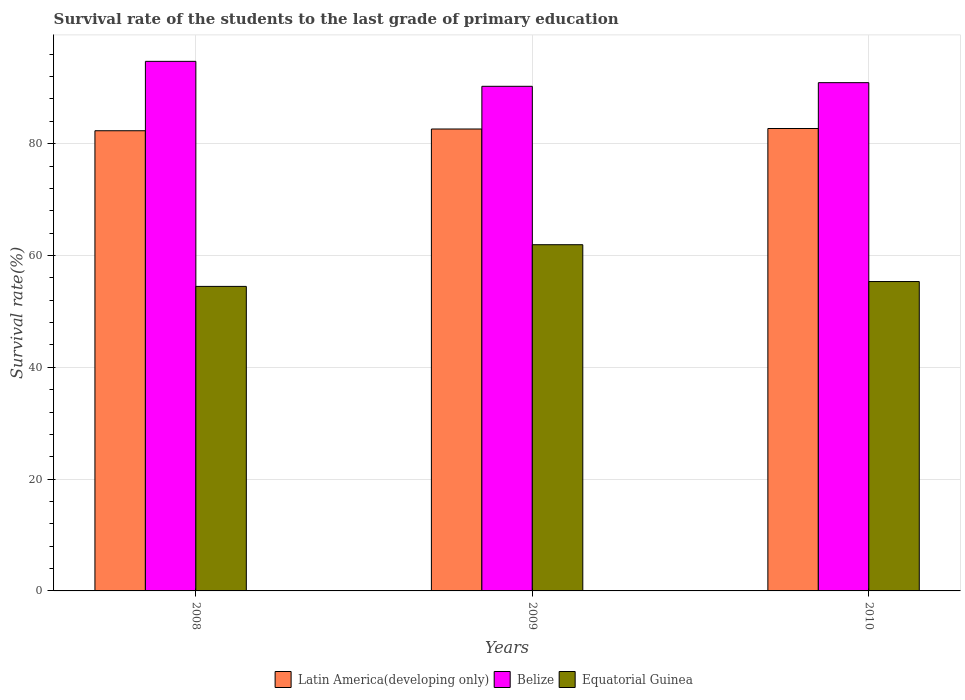How many different coloured bars are there?
Offer a terse response. 3. How many groups of bars are there?
Provide a short and direct response. 3. Are the number of bars per tick equal to the number of legend labels?
Offer a very short reply. Yes. Are the number of bars on each tick of the X-axis equal?
Ensure brevity in your answer.  Yes. How many bars are there on the 2nd tick from the left?
Make the answer very short. 3. How many bars are there on the 3rd tick from the right?
Keep it short and to the point. 3. What is the label of the 2nd group of bars from the left?
Offer a terse response. 2009. In how many cases, is the number of bars for a given year not equal to the number of legend labels?
Your answer should be compact. 0. What is the survival rate of the students in Equatorial Guinea in 2010?
Your response must be concise. 55.34. Across all years, what is the maximum survival rate of the students in Equatorial Guinea?
Ensure brevity in your answer.  61.93. Across all years, what is the minimum survival rate of the students in Equatorial Guinea?
Offer a terse response. 54.47. In which year was the survival rate of the students in Latin America(developing only) maximum?
Ensure brevity in your answer.  2010. In which year was the survival rate of the students in Equatorial Guinea minimum?
Keep it short and to the point. 2008. What is the total survival rate of the students in Latin America(developing only) in the graph?
Your answer should be very brief. 247.66. What is the difference between the survival rate of the students in Latin America(developing only) in 2008 and that in 2010?
Give a very brief answer. -0.4. What is the difference between the survival rate of the students in Equatorial Guinea in 2008 and the survival rate of the students in Belize in 2009?
Keep it short and to the point. -35.79. What is the average survival rate of the students in Belize per year?
Your answer should be compact. 91.97. In the year 2008, what is the difference between the survival rate of the students in Equatorial Guinea and survival rate of the students in Latin America(developing only)?
Provide a short and direct response. -27.85. In how many years, is the survival rate of the students in Belize greater than 72 %?
Offer a very short reply. 3. What is the ratio of the survival rate of the students in Equatorial Guinea in 2008 to that in 2009?
Your answer should be compact. 0.88. Is the survival rate of the students in Equatorial Guinea in 2008 less than that in 2010?
Make the answer very short. Yes. Is the difference between the survival rate of the students in Equatorial Guinea in 2008 and 2010 greater than the difference between the survival rate of the students in Latin America(developing only) in 2008 and 2010?
Offer a very short reply. No. What is the difference between the highest and the second highest survival rate of the students in Equatorial Guinea?
Offer a very short reply. 6.59. What is the difference between the highest and the lowest survival rate of the students in Equatorial Guinea?
Keep it short and to the point. 7.46. Is the sum of the survival rate of the students in Equatorial Guinea in 2008 and 2009 greater than the maximum survival rate of the students in Latin America(developing only) across all years?
Offer a very short reply. Yes. What does the 3rd bar from the left in 2009 represents?
Give a very brief answer. Equatorial Guinea. What does the 3rd bar from the right in 2009 represents?
Your response must be concise. Latin America(developing only). Is it the case that in every year, the sum of the survival rate of the students in Belize and survival rate of the students in Latin America(developing only) is greater than the survival rate of the students in Equatorial Guinea?
Make the answer very short. Yes. How many bars are there?
Your answer should be very brief. 9. What is the difference between two consecutive major ticks on the Y-axis?
Keep it short and to the point. 20. Does the graph contain any zero values?
Make the answer very short. No. Does the graph contain grids?
Offer a very short reply. Yes. What is the title of the graph?
Your answer should be compact. Survival rate of the students to the last grade of primary education. Does "Azerbaijan" appear as one of the legend labels in the graph?
Keep it short and to the point. No. What is the label or title of the Y-axis?
Provide a short and direct response. Survival rate(%). What is the Survival rate(%) of Latin America(developing only) in 2008?
Provide a short and direct response. 82.32. What is the Survival rate(%) in Belize in 2008?
Offer a terse response. 94.73. What is the Survival rate(%) of Equatorial Guinea in 2008?
Offer a terse response. 54.47. What is the Survival rate(%) of Latin America(developing only) in 2009?
Offer a terse response. 82.63. What is the Survival rate(%) of Belize in 2009?
Give a very brief answer. 90.27. What is the Survival rate(%) of Equatorial Guinea in 2009?
Keep it short and to the point. 61.93. What is the Survival rate(%) of Latin America(developing only) in 2010?
Offer a terse response. 82.72. What is the Survival rate(%) of Belize in 2010?
Ensure brevity in your answer.  90.92. What is the Survival rate(%) in Equatorial Guinea in 2010?
Ensure brevity in your answer.  55.34. Across all years, what is the maximum Survival rate(%) in Latin America(developing only)?
Offer a terse response. 82.72. Across all years, what is the maximum Survival rate(%) in Belize?
Your answer should be compact. 94.73. Across all years, what is the maximum Survival rate(%) in Equatorial Guinea?
Provide a succinct answer. 61.93. Across all years, what is the minimum Survival rate(%) in Latin America(developing only)?
Provide a short and direct response. 82.32. Across all years, what is the minimum Survival rate(%) in Belize?
Offer a terse response. 90.27. Across all years, what is the minimum Survival rate(%) of Equatorial Guinea?
Provide a short and direct response. 54.47. What is the total Survival rate(%) in Latin America(developing only) in the graph?
Provide a short and direct response. 247.66. What is the total Survival rate(%) of Belize in the graph?
Give a very brief answer. 275.91. What is the total Survival rate(%) of Equatorial Guinea in the graph?
Provide a short and direct response. 171.75. What is the difference between the Survival rate(%) in Latin America(developing only) in 2008 and that in 2009?
Your response must be concise. -0.31. What is the difference between the Survival rate(%) in Belize in 2008 and that in 2009?
Offer a very short reply. 4.46. What is the difference between the Survival rate(%) of Equatorial Guinea in 2008 and that in 2009?
Ensure brevity in your answer.  -7.46. What is the difference between the Survival rate(%) in Latin America(developing only) in 2008 and that in 2010?
Your answer should be very brief. -0.4. What is the difference between the Survival rate(%) in Belize in 2008 and that in 2010?
Make the answer very short. 3.81. What is the difference between the Survival rate(%) in Equatorial Guinea in 2008 and that in 2010?
Make the answer very short. -0.87. What is the difference between the Survival rate(%) of Latin America(developing only) in 2009 and that in 2010?
Provide a short and direct response. -0.09. What is the difference between the Survival rate(%) in Belize in 2009 and that in 2010?
Your response must be concise. -0.65. What is the difference between the Survival rate(%) in Equatorial Guinea in 2009 and that in 2010?
Ensure brevity in your answer.  6.59. What is the difference between the Survival rate(%) of Latin America(developing only) in 2008 and the Survival rate(%) of Belize in 2009?
Provide a succinct answer. -7.95. What is the difference between the Survival rate(%) in Latin America(developing only) in 2008 and the Survival rate(%) in Equatorial Guinea in 2009?
Ensure brevity in your answer.  20.39. What is the difference between the Survival rate(%) of Belize in 2008 and the Survival rate(%) of Equatorial Guinea in 2009?
Your answer should be compact. 32.8. What is the difference between the Survival rate(%) in Latin America(developing only) in 2008 and the Survival rate(%) in Belize in 2010?
Make the answer very short. -8.6. What is the difference between the Survival rate(%) of Latin America(developing only) in 2008 and the Survival rate(%) of Equatorial Guinea in 2010?
Your response must be concise. 26.98. What is the difference between the Survival rate(%) in Belize in 2008 and the Survival rate(%) in Equatorial Guinea in 2010?
Your answer should be very brief. 39.39. What is the difference between the Survival rate(%) of Latin America(developing only) in 2009 and the Survival rate(%) of Belize in 2010?
Offer a very short reply. -8.29. What is the difference between the Survival rate(%) of Latin America(developing only) in 2009 and the Survival rate(%) of Equatorial Guinea in 2010?
Your response must be concise. 27.29. What is the difference between the Survival rate(%) in Belize in 2009 and the Survival rate(%) in Equatorial Guinea in 2010?
Provide a short and direct response. 34.92. What is the average Survival rate(%) in Latin America(developing only) per year?
Offer a terse response. 82.55. What is the average Survival rate(%) of Belize per year?
Your answer should be compact. 91.97. What is the average Survival rate(%) in Equatorial Guinea per year?
Provide a short and direct response. 57.25. In the year 2008, what is the difference between the Survival rate(%) of Latin America(developing only) and Survival rate(%) of Belize?
Your answer should be compact. -12.41. In the year 2008, what is the difference between the Survival rate(%) of Latin America(developing only) and Survival rate(%) of Equatorial Guinea?
Ensure brevity in your answer.  27.84. In the year 2008, what is the difference between the Survival rate(%) in Belize and Survival rate(%) in Equatorial Guinea?
Offer a terse response. 40.26. In the year 2009, what is the difference between the Survival rate(%) of Latin America(developing only) and Survival rate(%) of Belize?
Give a very brief answer. -7.64. In the year 2009, what is the difference between the Survival rate(%) in Latin America(developing only) and Survival rate(%) in Equatorial Guinea?
Provide a succinct answer. 20.7. In the year 2009, what is the difference between the Survival rate(%) in Belize and Survival rate(%) in Equatorial Guinea?
Your answer should be compact. 28.33. In the year 2010, what is the difference between the Survival rate(%) in Latin America(developing only) and Survival rate(%) in Belize?
Make the answer very short. -8.2. In the year 2010, what is the difference between the Survival rate(%) in Latin America(developing only) and Survival rate(%) in Equatorial Guinea?
Your response must be concise. 27.38. In the year 2010, what is the difference between the Survival rate(%) of Belize and Survival rate(%) of Equatorial Guinea?
Your response must be concise. 35.58. What is the ratio of the Survival rate(%) of Belize in 2008 to that in 2009?
Offer a very short reply. 1.05. What is the ratio of the Survival rate(%) in Equatorial Guinea in 2008 to that in 2009?
Keep it short and to the point. 0.88. What is the ratio of the Survival rate(%) in Latin America(developing only) in 2008 to that in 2010?
Provide a short and direct response. 1. What is the ratio of the Survival rate(%) of Belize in 2008 to that in 2010?
Provide a short and direct response. 1.04. What is the ratio of the Survival rate(%) in Equatorial Guinea in 2008 to that in 2010?
Make the answer very short. 0.98. What is the ratio of the Survival rate(%) of Equatorial Guinea in 2009 to that in 2010?
Ensure brevity in your answer.  1.12. What is the difference between the highest and the second highest Survival rate(%) of Latin America(developing only)?
Your answer should be very brief. 0.09. What is the difference between the highest and the second highest Survival rate(%) in Belize?
Ensure brevity in your answer.  3.81. What is the difference between the highest and the second highest Survival rate(%) of Equatorial Guinea?
Make the answer very short. 6.59. What is the difference between the highest and the lowest Survival rate(%) in Latin America(developing only)?
Your answer should be very brief. 0.4. What is the difference between the highest and the lowest Survival rate(%) of Belize?
Make the answer very short. 4.46. What is the difference between the highest and the lowest Survival rate(%) in Equatorial Guinea?
Provide a short and direct response. 7.46. 